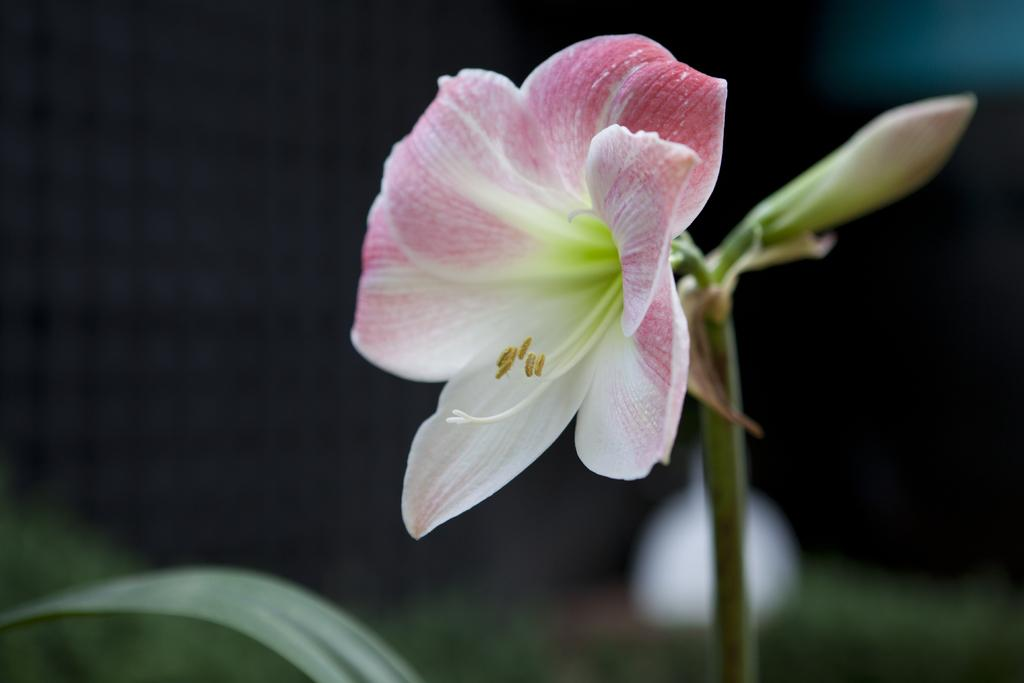What is the main subject of the image? The main subject of the image is a flower. Can you describe the flower in more detail? Yes, the flower has a bud and a leaf. What can be observed about the background of the image? The background of the image is blurry. How many crates are stacked next to the flower in the image? There are no crates present in the image; it features a flower with a bud and a leaf against a blurry background. What type of twig is entwined with the flower in the image? There is no twig entwined with the flower in the image; it only has a bud and a leaf. 